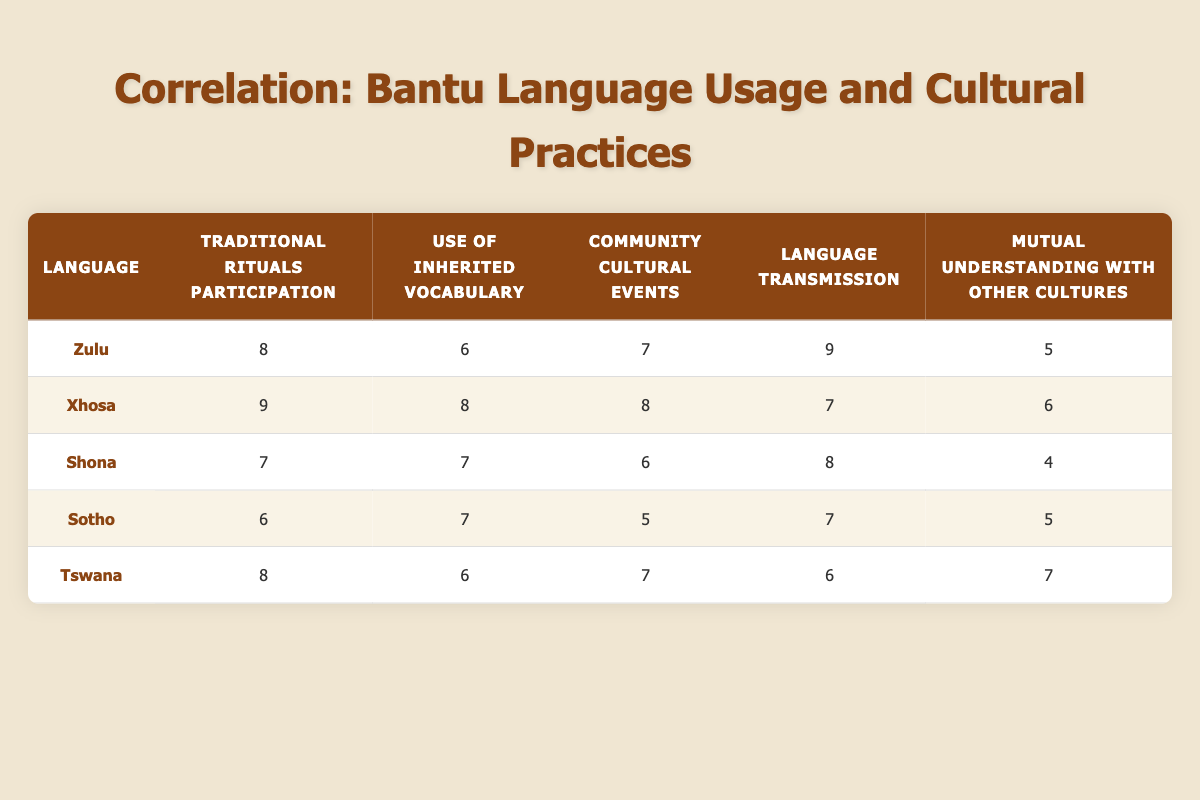What is the Traditional Rituals Participation score for Xhosa? The table clearly shows that the score for Traditional Rituals Participation for Xhosa is listed in the second column. It is directly stated as 9.
Answer: 9 Which language has the highest Community Cultural Events score? By examining the Community Cultural Events column, we can see that both Xhosa and Zulu have a score of 8, which is the highest among all languages listed.
Answer: Xhosa and Zulu What is the average score for Language Transmission across all languages? To find the average, we will sum the scores for Language Transmission: 9 (Zulu) + 7 (Xhosa) + 8 (Shona) + 7 (Sotho) + 6 (Tswana) = 37. There are 5 languages, so the average is 37/5 = 7.4.
Answer: 7.4 Is the Use of Inherited Vocabulary score for Tswana higher than the Mutual Understanding with Other Cultures score? Looking at both the Use of Inherited Vocabulary and Mutual Understanding with Other Cultures columns for Tswana, the score for Use of Inherited Vocabulary is 6, while for Mutual Understanding, it is 7. Thus, the statement is false.
Answer: No Which language has the lowest score in Mutual Understanding with Other Cultures, and what is the score? By examining the Mutual Understanding with Other Cultures column, the lowest score is 4, which corresponds to Shona.
Answer: Shona, 4 If we add the scores of Traditional Rituals Participation for Zulu and Shona, what is the result? The Traditional Rituals Participation scores for Zulu and Shona are 8 and 7, respectively. Adding these gives us 8 + 7 = 15.
Answer: 15 What is the score difference in Community Cultural Events between Xhosa and Sotho? Xhosa has a score of 8 in Community Cultural Events, while Sotho has a score of 5. The difference is calculated as 8 - 5 = 3.
Answer: 3 Which language has the highest score for Use of Inherited Vocabulary and what is the score? The scores for Use of Inherited Vocabulary reveal that Xhosa has the highest score at 8.
Answer: Xhosa, 8 Are Zulu and Tswana scores for Traditional Rituals Participation the same? By checking the Traditional Rituals Participation scores, we find that Zulu has a score of 8, while Tswana also has a score of 8. Therefore, they are the same.
Answer: Yes 